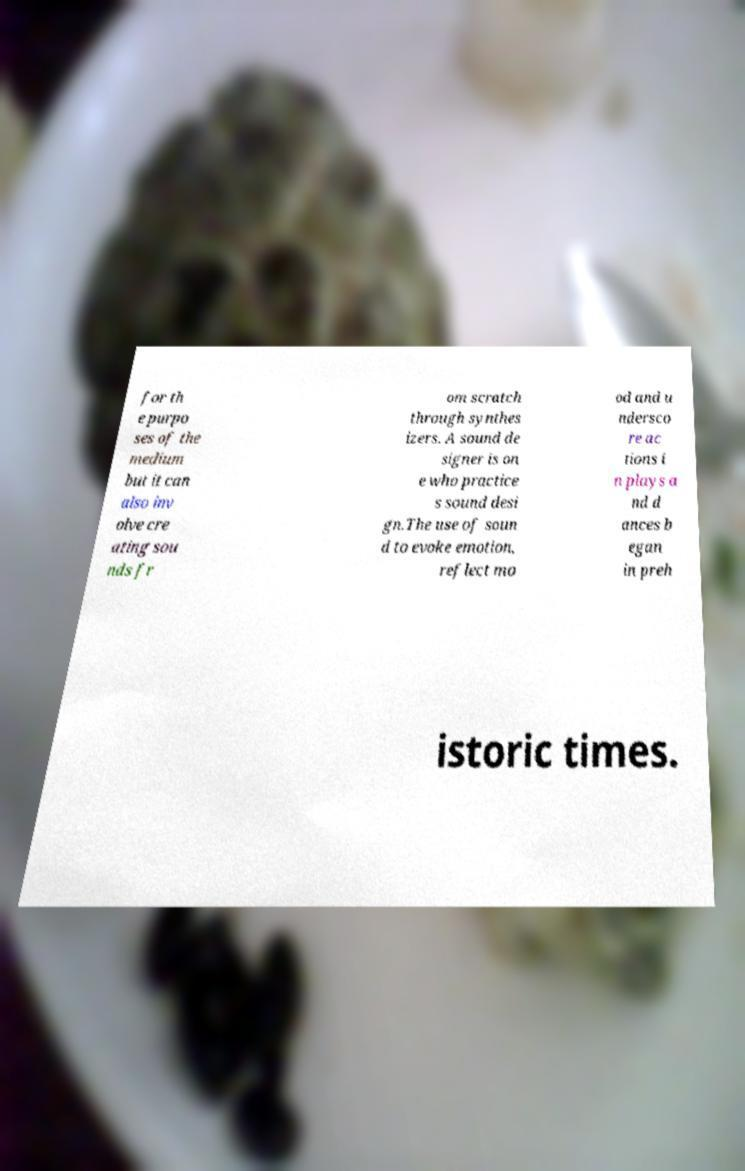Please identify and transcribe the text found in this image. for th e purpo ses of the medium but it can also inv olve cre ating sou nds fr om scratch through synthes izers. A sound de signer is on e who practice s sound desi gn.The use of soun d to evoke emotion, reflect mo od and u ndersco re ac tions i n plays a nd d ances b egan in preh istoric times. 